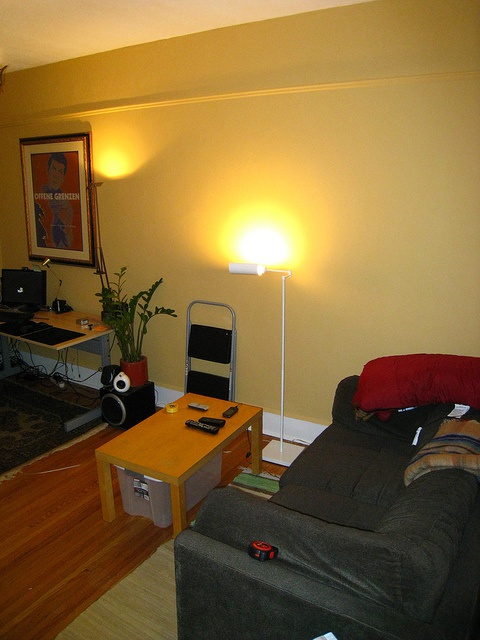Describe the objects in this image and their specific colors. I can see couch in tan, black, gray, and darkgreen tones, chair in tan, black, gray, and olive tones, potted plant in tan, black, olive, and maroon tones, tv in tan, black, olive, maroon, and gray tones, and keyboard in tan, black, and maroon tones in this image. 